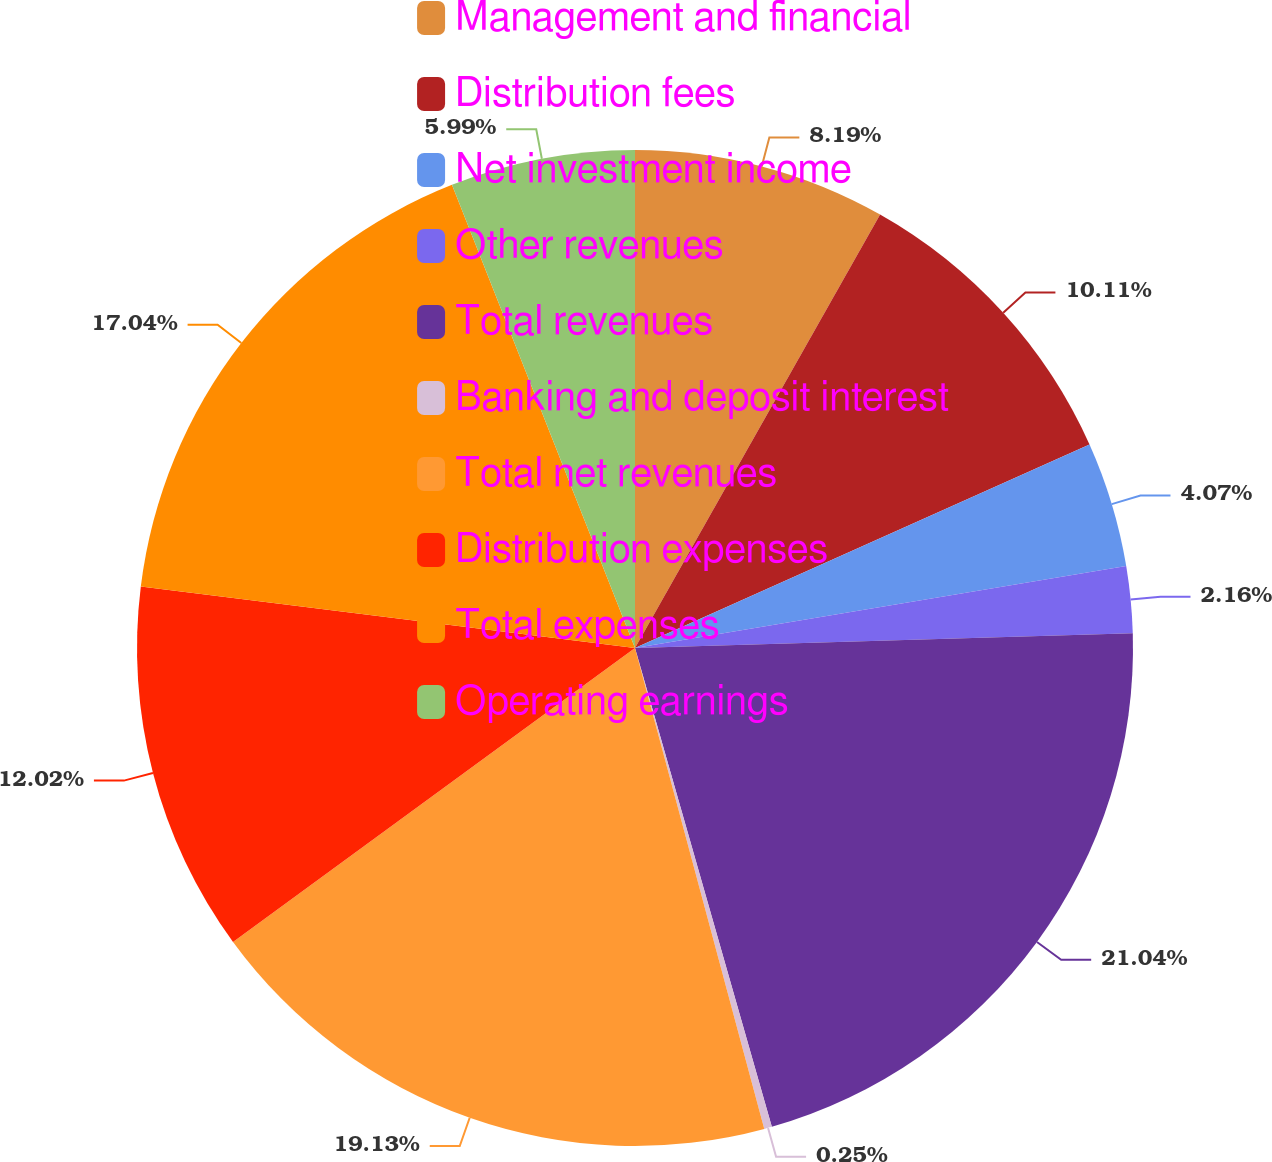Convert chart to OTSL. <chart><loc_0><loc_0><loc_500><loc_500><pie_chart><fcel>Management and financial<fcel>Distribution fees<fcel>Net investment income<fcel>Other revenues<fcel>Total revenues<fcel>Banking and deposit interest<fcel>Total net revenues<fcel>Distribution expenses<fcel>Total expenses<fcel>Operating earnings<nl><fcel>8.19%<fcel>10.11%<fcel>4.07%<fcel>2.16%<fcel>21.04%<fcel>0.25%<fcel>19.13%<fcel>12.02%<fcel>17.04%<fcel>5.99%<nl></chart> 